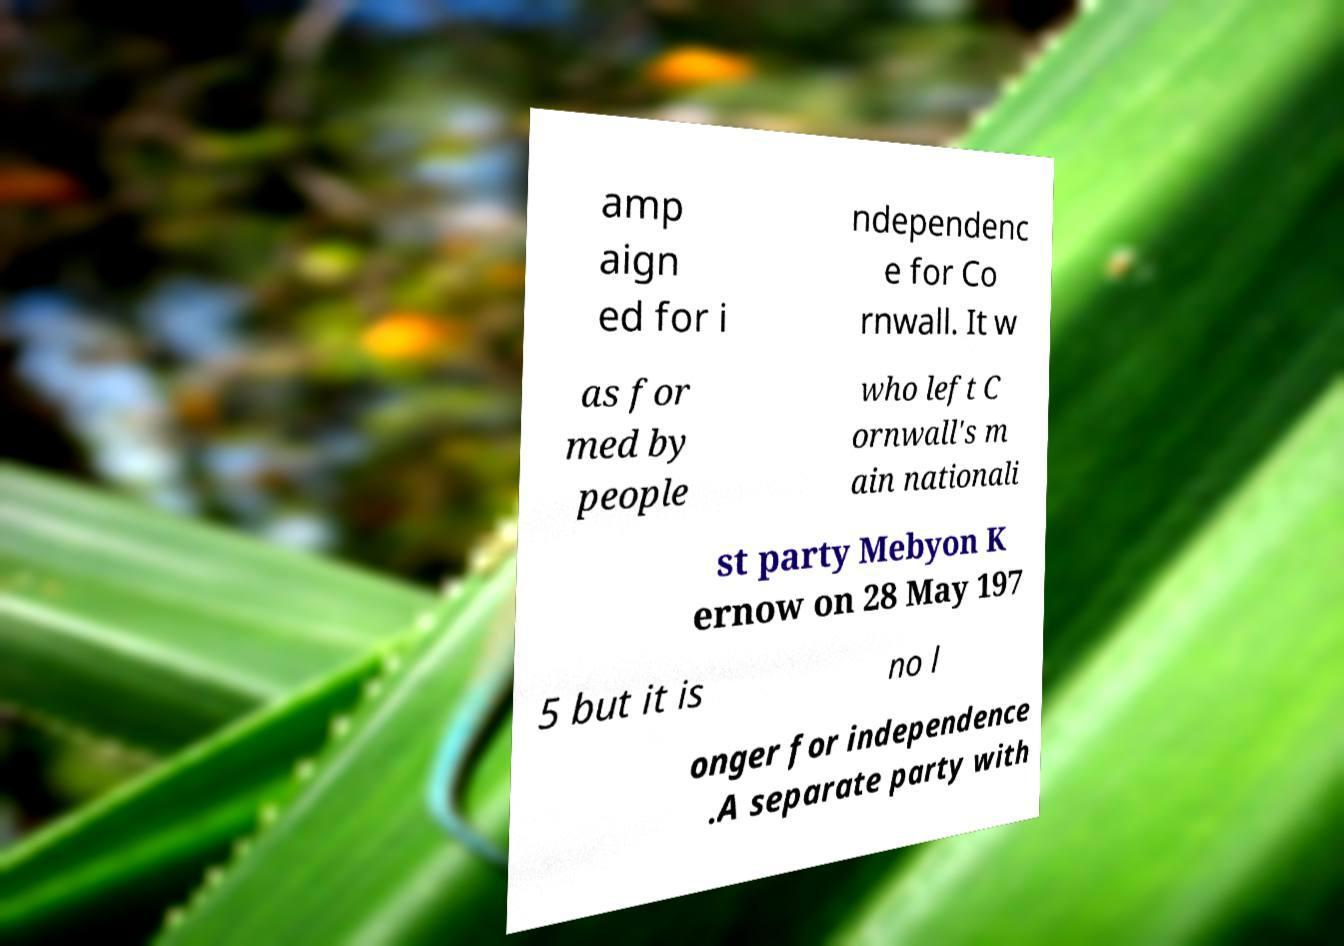What messages or text are displayed in this image? I need them in a readable, typed format. amp aign ed for i ndependenc e for Co rnwall. It w as for med by people who left C ornwall's m ain nationali st party Mebyon K ernow on 28 May 197 5 but it is no l onger for independence .A separate party with 